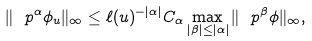Convert formula to latex. <formula><loc_0><loc_0><loc_500><loc_500>\| \ p ^ { \alpha } \phi _ { u } \| _ { \infty } \leq \ell ( u ) ^ { - | \alpha | } C _ { \alpha } \max _ { | \beta | \leq | \alpha | } \| \ p ^ { \beta } \phi \| _ { \infty } ,</formula> 